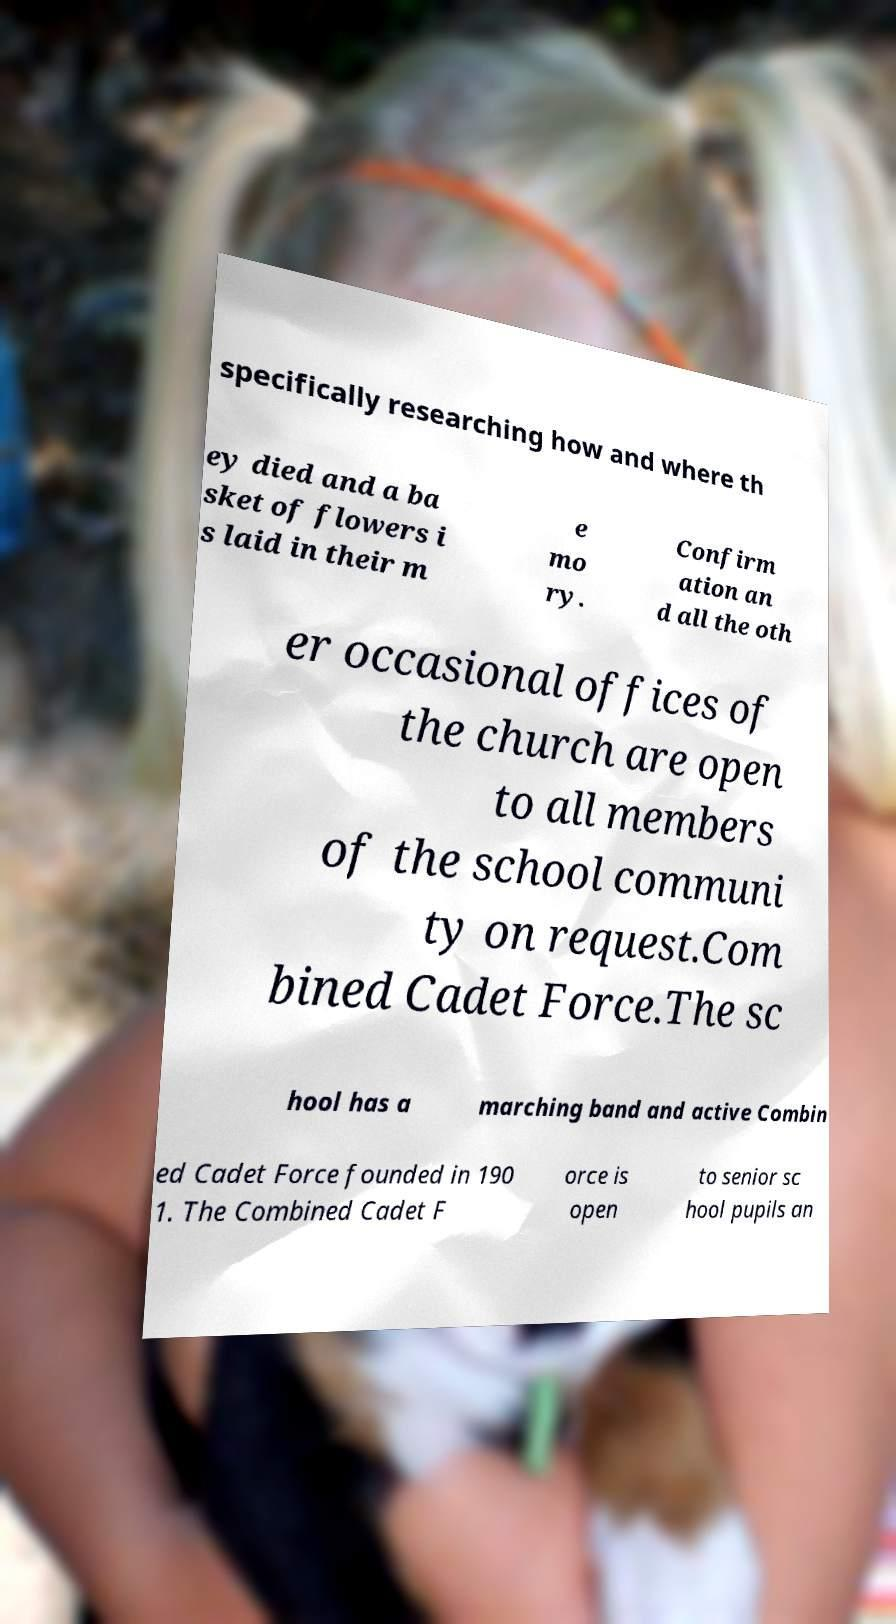What messages or text are displayed in this image? I need them in a readable, typed format. specifically researching how and where th ey died and a ba sket of flowers i s laid in their m e mo ry. Confirm ation an d all the oth er occasional offices of the church are open to all members of the school communi ty on request.Com bined Cadet Force.The sc hool has a marching band and active Combin ed Cadet Force founded in 190 1. The Combined Cadet F orce is open to senior sc hool pupils an 